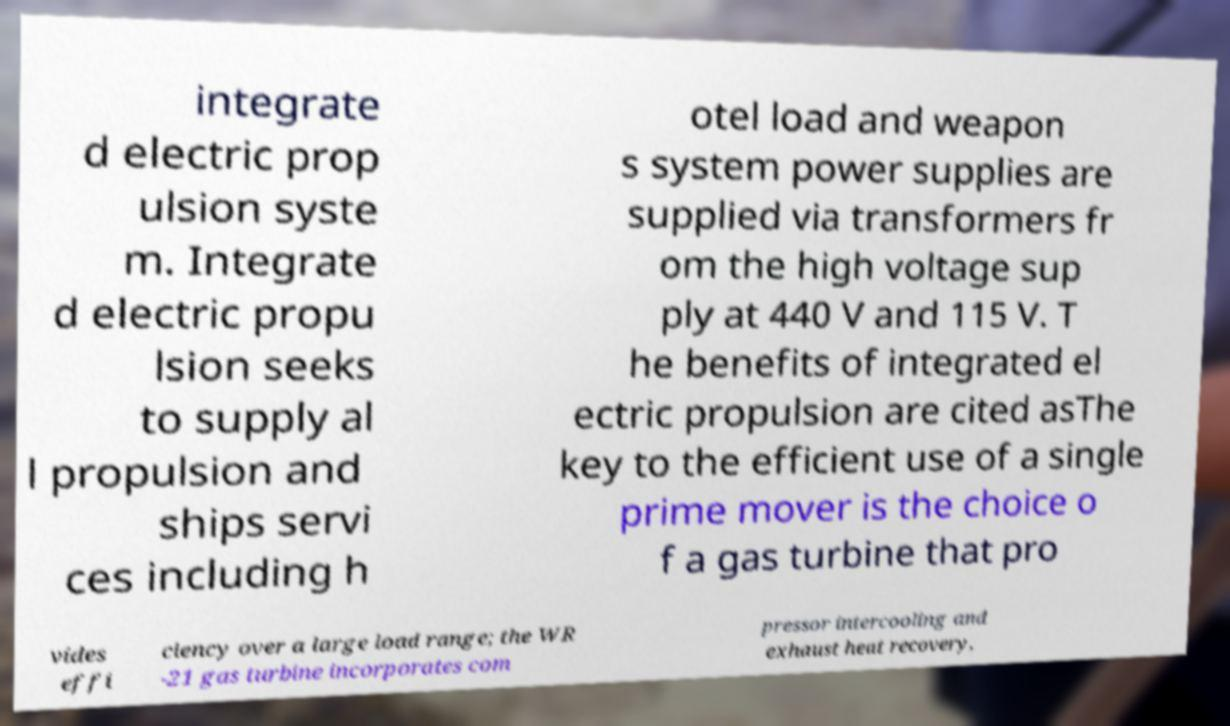There's text embedded in this image that I need extracted. Can you transcribe it verbatim? integrate d electric prop ulsion syste m. Integrate d electric propu lsion seeks to supply al l propulsion and ships servi ces including h otel load and weapon s system power supplies are supplied via transformers fr om the high voltage sup ply at 440 V and 115 V. T he benefits of integrated el ectric propulsion are cited asThe key to the efficient use of a single prime mover is the choice o f a gas turbine that pro vides effi ciency over a large load range; the WR -21 gas turbine incorporates com pressor intercooling and exhaust heat recovery, 